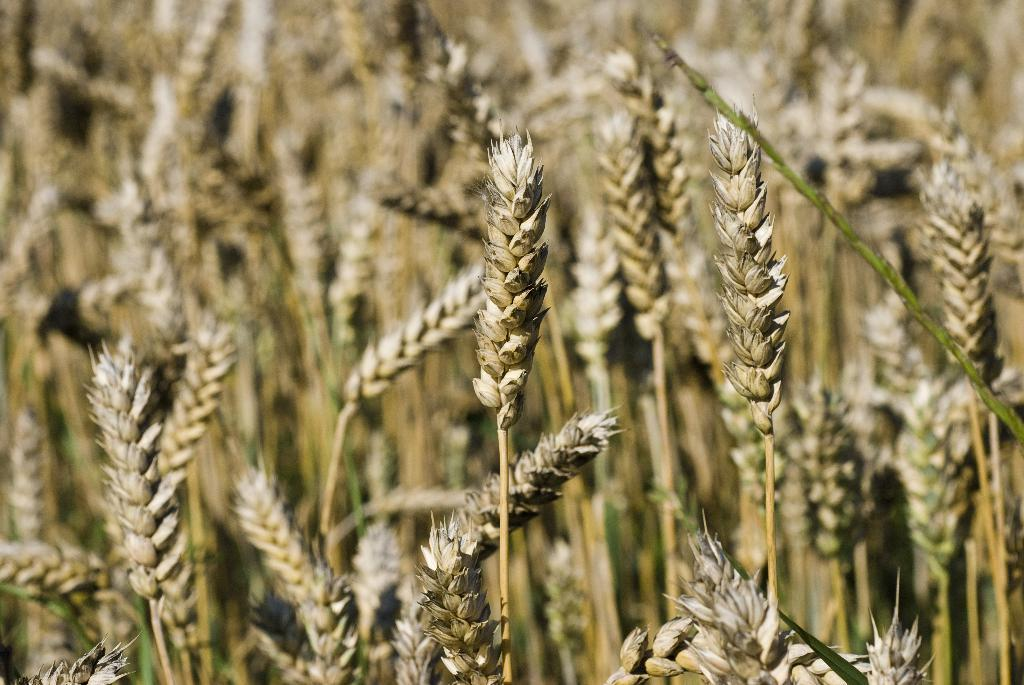What type of plants are in the image? There are wheat plants in the image. Can you describe the background of the image? The background of the image is blurred. What musical instrument is being played in the image? There is no musical instrument present in the image; it only features wheat plants and a blurred background. 